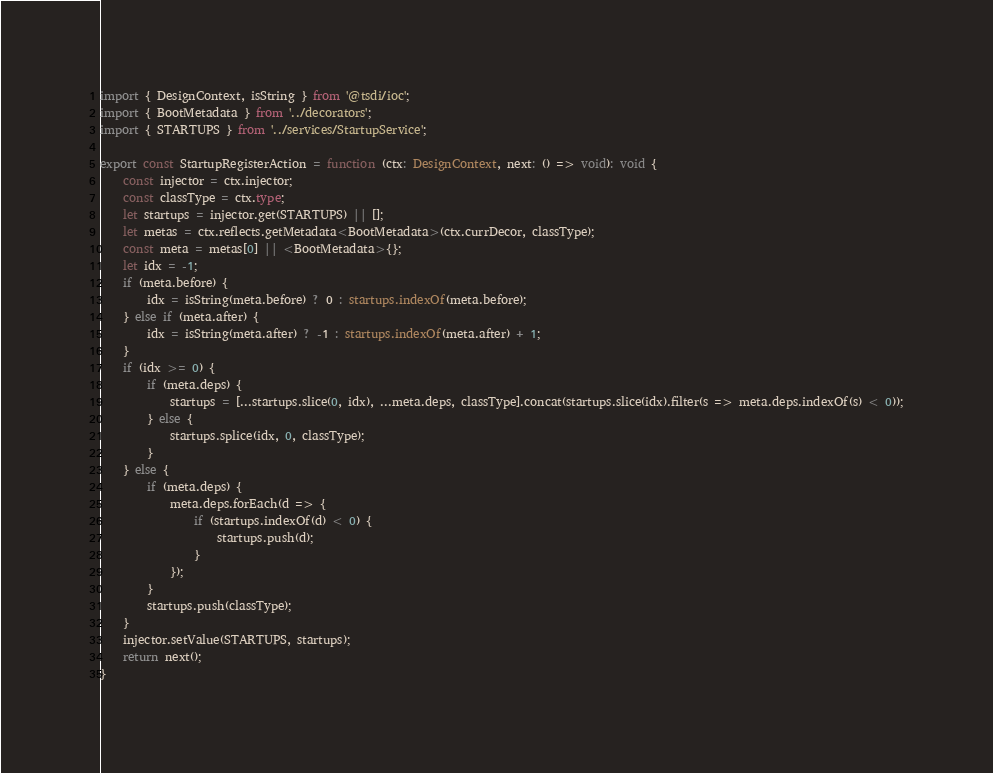Convert code to text. <code><loc_0><loc_0><loc_500><loc_500><_TypeScript_>import { DesignContext, isString } from '@tsdi/ioc';
import { BootMetadata } from '../decorators';
import { STARTUPS } from '../services/StartupService';

export const StartupRegisterAction = function (ctx: DesignContext, next: () => void): void {
    const injector = ctx.injector;
    const classType = ctx.type;
    let startups = injector.get(STARTUPS) || [];
    let metas = ctx.reflects.getMetadata<BootMetadata>(ctx.currDecor, classType);
    const meta = metas[0] || <BootMetadata>{};
    let idx = -1;
    if (meta.before) {
        idx = isString(meta.before) ? 0 : startups.indexOf(meta.before);
    } else if (meta.after) {
        idx = isString(meta.after) ? -1 : startups.indexOf(meta.after) + 1;
    }
    if (idx >= 0) {
        if (meta.deps) {
            startups = [...startups.slice(0, idx), ...meta.deps, classType].concat(startups.slice(idx).filter(s => meta.deps.indexOf(s) < 0));
        } else {
            startups.splice(idx, 0, classType);
        }
    } else {
        if (meta.deps) {
            meta.deps.forEach(d => {
                if (startups.indexOf(d) < 0) {
                    startups.push(d);
                }
            });
        }
        startups.push(classType);
    }
    injector.setValue(STARTUPS, startups);
    return next();
}
</code> 